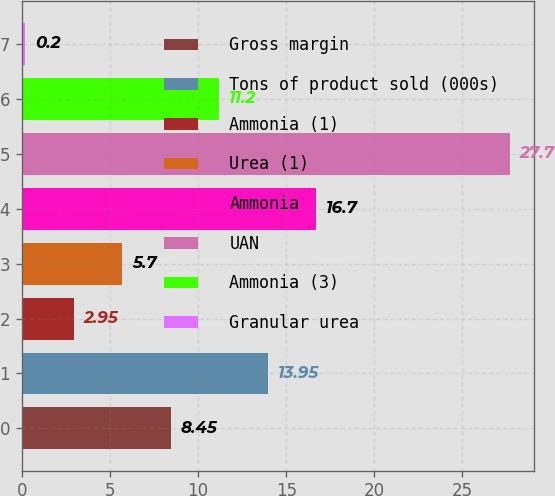Convert chart to OTSL. <chart><loc_0><loc_0><loc_500><loc_500><bar_chart><fcel>Gross margin<fcel>Tons of product sold (000s)<fcel>Ammonia (1)<fcel>Urea (1)<fcel>Ammonia<fcel>UAN<fcel>Ammonia (3)<fcel>Granular urea<nl><fcel>8.45<fcel>13.95<fcel>2.95<fcel>5.7<fcel>16.7<fcel>27.7<fcel>11.2<fcel>0.2<nl></chart> 